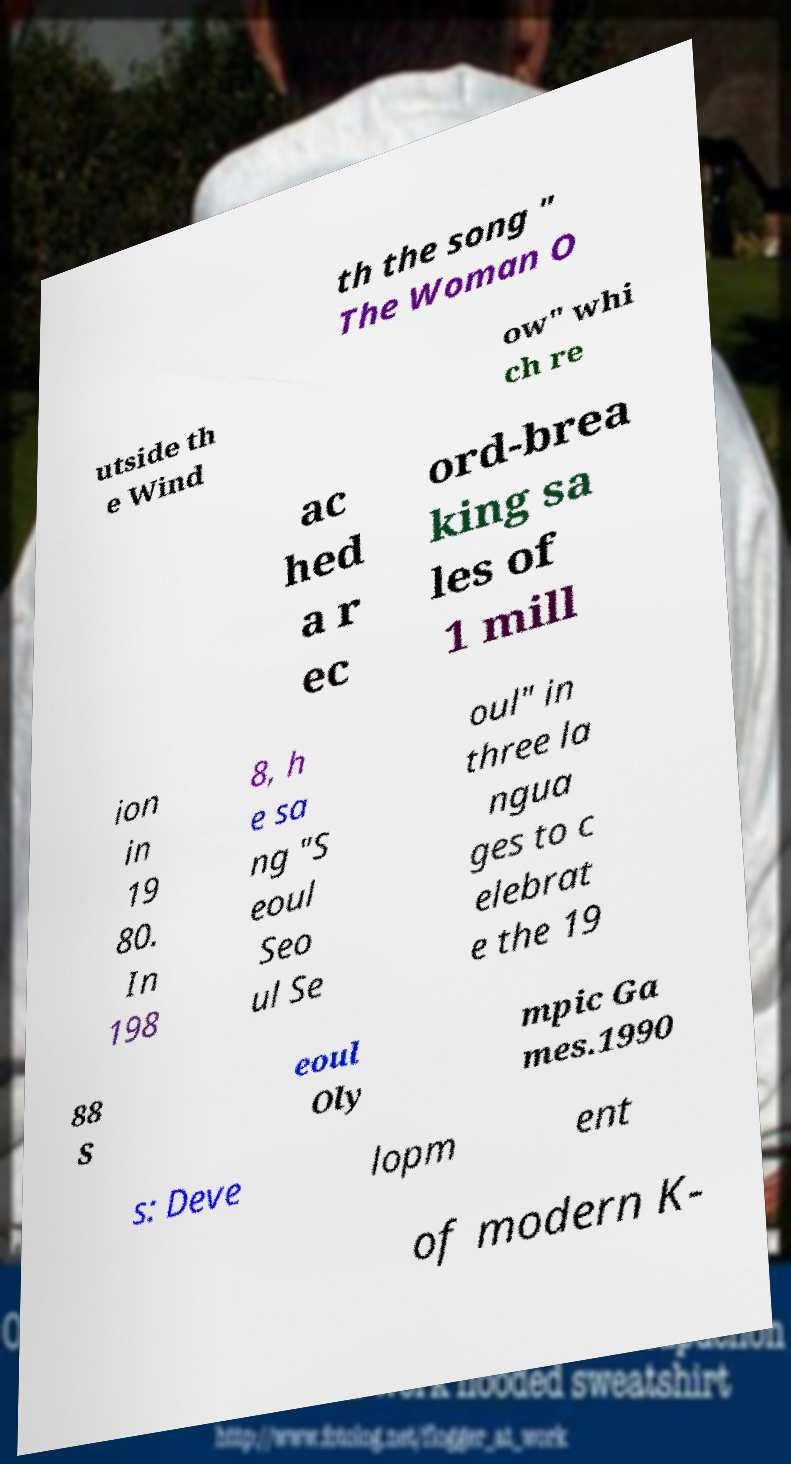There's text embedded in this image that I need extracted. Can you transcribe it verbatim? th the song " The Woman O utside th e Wind ow" whi ch re ac hed a r ec ord-brea king sa les of 1 mill ion in 19 80. In 198 8, h e sa ng "S eoul Seo ul Se oul" in three la ngua ges to c elebrat e the 19 88 S eoul Oly mpic Ga mes.1990 s: Deve lopm ent of modern K- 